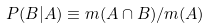<formula> <loc_0><loc_0><loc_500><loc_500>P ( B | A ) \equiv m ( A \cap B ) / m ( A )</formula> 